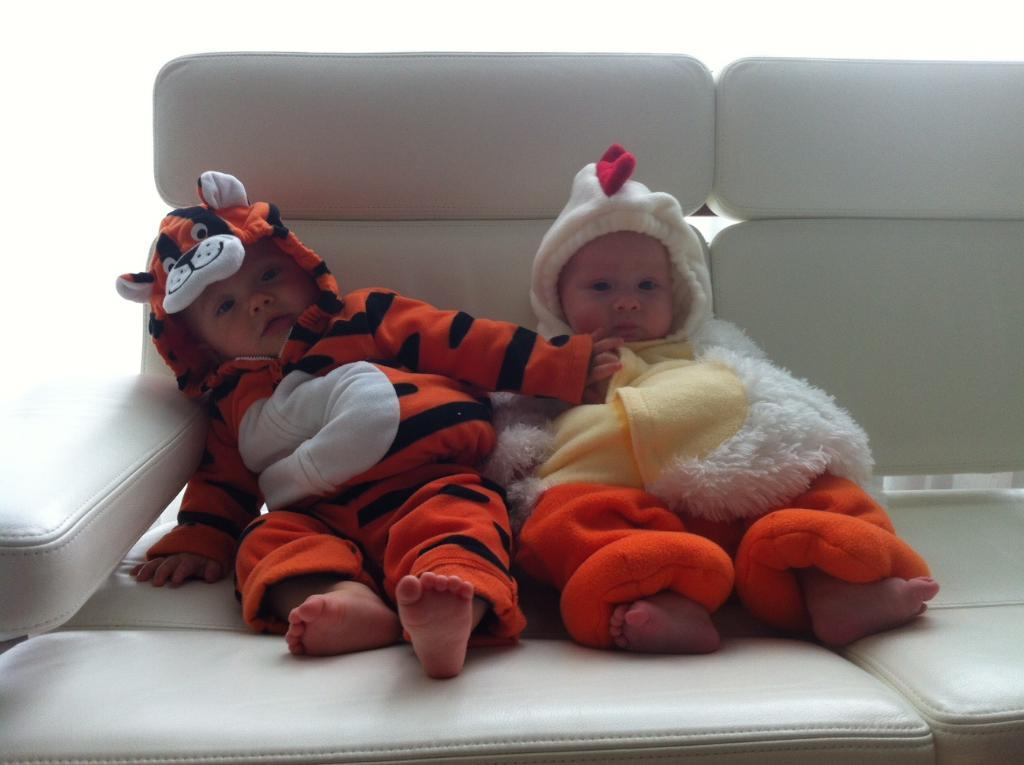How many children are present in the image? There are two children in the image. What are the children doing in the image? The children are sitting on a couch. What color is the background of the image? The background of the image is white. What type of vest is the fireman wearing in the image? There is no fireman or vest present in the image; it features two children sitting on a couch with a white background. 